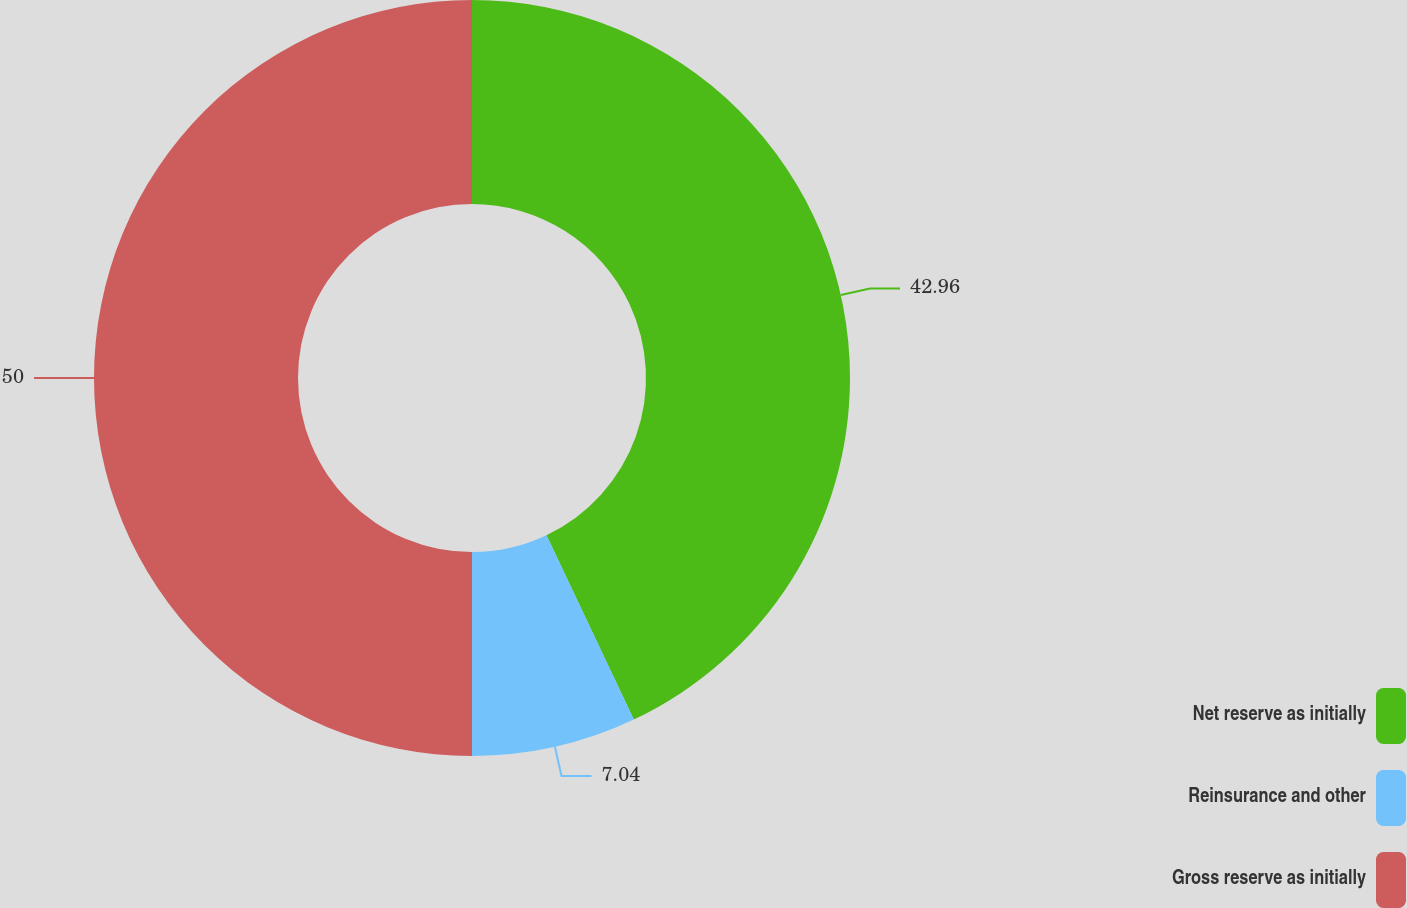Convert chart. <chart><loc_0><loc_0><loc_500><loc_500><pie_chart><fcel>Net reserve as initially<fcel>Reinsurance and other<fcel>Gross reserve as initially<nl><fcel>42.96%<fcel>7.04%<fcel>50.0%<nl></chart> 